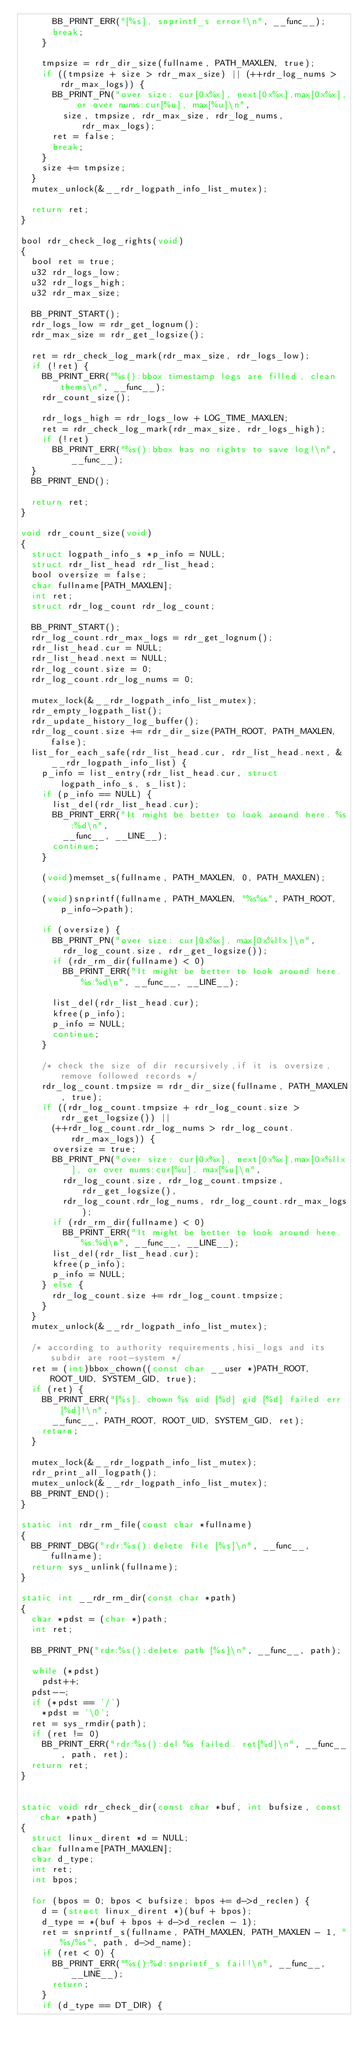Convert code to text. <code><loc_0><loc_0><loc_500><loc_500><_C_>			BB_PRINT_ERR("[%s], snprintf_s error!\n", __func__);
			break;
		}

		tmpsize = rdr_dir_size(fullname, PATH_MAXLEN, true);
		if ((tmpsize + size > rdr_max_size) || (++rdr_log_nums > rdr_max_logs)) {
			BB_PRINT_PN("over size: cur[0x%x], next[0x%x],max[0x%x], or over nums:cur[%u], max[%u]\n",
				size, tmpsize, rdr_max_size, rdr_log_nums, rdr_max_logs);
			ret = false;
			break;
		}
		size += tmpsize;
	}
	mutex_unlock(&__rdr_logpath_info_list_mutex);

	return ret;
}

bool rdr_check_log_rights(void)
{
	bool ret = true;
	u32 rdr_logs_low;
	u32 rdr_logs_high;
	u32 rdr_max_size;

	BB_PRINT_START();
	rdr_logs_low = rdr_get_lognum();
	rdr_max_size = rdr_get_logsize();

	ret = rdr_check_log_mark(rdr_max_size, rdr_logs_low);
	if (!ret) {
		BB_PRINT_ERR("%s():bbox timestamp logs are filled, clean thems\n", __func__);
		rdr_count_size();

		rdr_logs_high = rdr_logs_low + LOG_TIME_MAXLEN;
		ret = rdr_check_log_mark(rdr_max_size, rdr_logs_high);
		if (!ret)
			BB_PRINT_ERR("%s():bbox has no rights to save log!\n", __func__);
	}
	BB_PRINT_END();

	return ret;
}

void rdr_count_size(void)
{
	struct logpath_info_s *p_info = NULL;
	struct rdr_list_head rdr_list_head;
	bool oversize = false;
	char fullname[PATH_MAXLEN];
	int ret;
	struct rdr_log_count rdr_log_count;

	BB_PRINT_START();
	rdr_log_count.rdr_max_logs = rdr_get_lognum();
	rdr_list_head.cur = NULL;
	rdr_list_head.next = NULL;
	rdr_log_count.size = 0;
	rdr_log_count.rdr_log_nums = 0;

	mutex_lock(&__rdr_logpath_info_list_mutex);
	rdr_empty_logpath_list();
	rdr_update_history_log_buffer();
	rdr_log_count.size += rdr_dir_size(PATH_ROOT, PATH_MAXLEN, false);
	list_for_each_safe(rdr_list_head.cur, rdr_list_head.next, &__rdr_logpath_info_list) {
		p_info = list_entry(rdr_list_head.cur, struct logpath_info_s, s_list);
		if (p_info == NULL) {
			list_del(rdr_list_head.cur);
			BB_PRINT_ERR("It might be better to look around here. %s:%d\n",
				__func__, __LINE__);
			continue;
		}

		(void)memset_s(fullname, PATH_MAXLEN, 0, PATH_MAXLEN);

		(void)snprintf(fullname, PATH_MAXLEN, "%s%s", PATH_ROOT, p_info->path);

		if (oversize) {
			BB_PRINT_PN("over size: cur[0x%x], max[0x%llx]\n",
				rdr_log_count.size, rdr_get_logsize());
			if (rdr_rm_dir(fullname) < 0)
				BB_PRINT_ERR("It might be better to look around here. %s:%d\n", __func__, __LINE__);

			list_del(rdr_list_head.cur);
			kfree(p_info);
			p_info = NULL;
			continue;
		}

		/* check the size of dir recursively,if it is oversize,remove followed records */
		rdr_log_count.tmpsize = rdr_dir_size(fullname, PATH_MAXLEN, true);
		if ((rdr_log_count.tmpsize + rdr_log_count.size > rdr_get_logsize()) ||
			(++rdr_log_count.rdr_log_nums > rdr_log_count.rdr_max_logs)) {
			oversize = true;
			BB_PRINT_PN("over size: cur[0x%x], next[0x%x],max[0x%llx], or over nums:cur[%u], max[%u]\n",
				rdr_log_count.size, rdr_log_count.tmpsize, rdr_get_logsize(),
				rdr_log_count.rdr_log_nums, rdr_log_count.rdr_max_logs);
			if (rdr_rm_dir(fullname) < 0)
				BB_PRINT_ERR("It might be better to look around here. %s:%d\n", __func__, __LINE__);
			list_del(rdr_list_head.cur);
			kfree(p_info);
			p_info = NULL;
		} else {
			rdr_log_count.size += rdr_log_count.tmpsize;
		}
	}
	mutex_unlock(&__rdr_logpath_info_list_mutex);

	/* according to authority requirements,hisi_logs and its subdir are root-system */
	ret = (int)bbox_chown((const char __user *)PATH_ROOT, ROOT_UID, SYSTEM_GID, true);
	if (ret) {
		BB_PRINT_ERR("[%s], chown %s uid [%d] gid [%d] failed err [%d]!\n",
			__func__, PATH_ROOT, ROOT_UID, SYSTEM_GID, ret);
		return;
	}

	mutex_lock(&__rdr_logpath_info_list_mutex);
	rdr_print_all_logpath();
	mutex_unlock(&__rdr_logpath_info_list_mutex);
	BB_PRINT_END();
}

static int rdr_rm_file(const char *fullname)
{
	BB_PRINT_DBG("rdr:%s():delete file [%s]\n", __func__, fullname);
	return sys_unlink(fullname);
}

static int __rdr_rm_dir(const char *path)
{
	char *pdst = (char *)path;
	int ret;

	BB_PRINT_PN("rdr:%s():delete path [%s]\n", __func__, path);

	while (*pdst)
		pdst++;
	pdst--;
	if (*pdst == '/')
		*pdst = '\0';
	ret = sys_rmdir(path);
	if (ret != 0)
		BB_PRINT_ERR("rdr:%s():del %s failed. ret[%d]\n", __func__, path, ret);
	return ret;
}


static void rdr_check_dir(const char *buf, int bufsize, const char *path)
{
	struct linux_dirent *d = NULL;
	char fullname[PATH_MAXLEN];
	char d_type;
	int ret;
	int bpos;

	for (bpos = 0; bpos < bufsize; bpos += d->d_reclen) {
		d = (struct linux_dirent *)(buf + bpos);
		d_type = *(buf + bpos + d->d_reclen - 1);
		ret = snprintf_s(fullname, PATH_MAXLEN, PATH_MAXLEN - 1, "%s/%s", path, d->d_name);
		if (ret < 0) {
			BB_PRINT_ERR("%s():%d:snprintf_s fail!\n", __func__, __LINE__);
			return;
		}
		if (d_type == DT_DIR) {</code> 